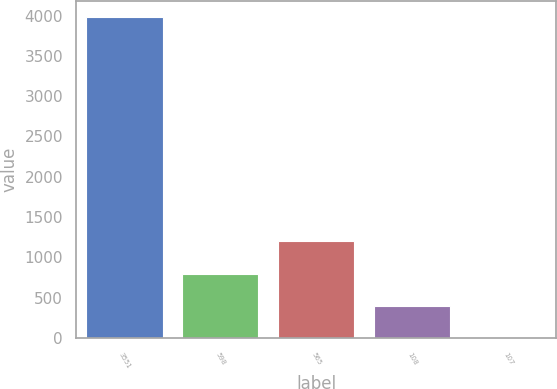Convert chart to OTSL. <chart><loc_0><loc_0><loc_500><loc_500><bar_chart><fcel>3551<fcel>598<fcel>565<fcel>108<fcel>107<nl><fcel>3983<fcel>797.31<fcel>1195.52<fcel>399.1<fcel>0.89<nl></chart> 